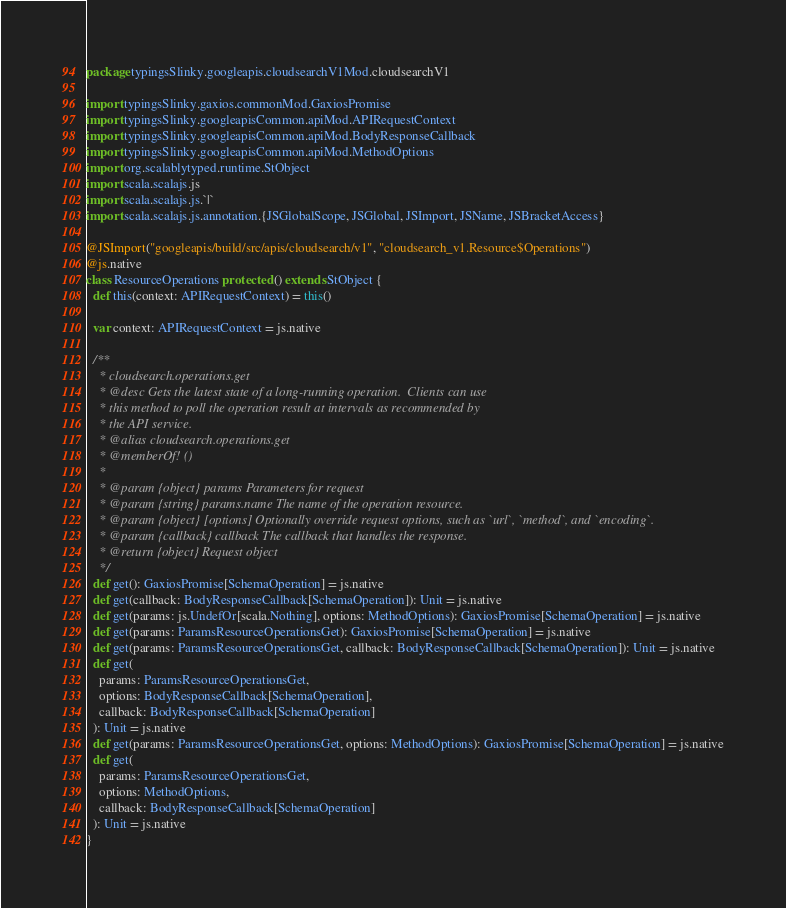Convert code to text. <code><loc_0><loc_0><loc_500><loc_500><_Scala_>package typingsSlinky.googleapis.cloudsearchV1Mod.cloudsearchV1

import typingsSlinky.gaxios.commonMod.GaxiosPromise
import typingsSlinky.googleapisCommon.apiMod.APIRequestContext
import typingsSlinky.googleapisCommon.apiMod.BodyResponseCallback
import typingsSlinky.googleapisCommon.apiMod.MethodOptions
import org.scalablytyped.runtime.StObject
import scala.scalajs.js
import scala.scalajs.js.`|`
import scala.scalajs.js.annotation.{JSGlobalScope, JSGlobal, JSImport, JSName, JSBracketAccess}

@JSImport("googleapis/build/src/apis/cloudsearch/v1", "cloudsearch_v1.Resource$Operations")
@js.native
class ResourceOperations protected () extends StObject {
  def this(context: APIRequestContext) = this()
  
  var context: APIRequestContext = js.native
  
  /**
    * cloudsearch.operations.get
    * @desc Gets the latest state of a long-running operation.  Clients can use
    * this method to poll the operation result at intervals as recommended by
    * the API service.
    * @alias cloudsearch.operations.get
    * @memberOf! ()
    *
    * @param {object} params Parameters for request
    * @param {string} params.name The name of the operation resource.
    * @param {object} [options] Optionally override request options, such as `url`, `method`, and `encoding`.
    * @param {callback} callback The callback that handles the response.
    * @return {object} Request object
    */
  def get(): GaxiosPromise[SchemaOperation] = js.native
  def get(callback: BodyResponseCallback[SchemaOperation]): Unit = js.native
  def get(params: js.UndefOr[scala.Nothing], options: MethodOptions): GaxiosPromise[SchemaOperation] = js.native
  def get(params: ParamsResourceOperationsGet): GaxiosPromise[SchemaOperation] = js.native
  def get(params: ParamsResourceOperationsGet, callback: BodyResponseCallback[SchemaOperation]): Unit = js.native
  def get(
    params: ParamsResourceOperationsGet,
    options: BodyResponseCallback[SchemaOperation],
    callback: BodyResponseCallback[SchemaOperation]
  ): Unit = js.native
  def get(params: ParamsResourceOperationsGet, options: MethodOptions): GaxiosPromise[SchemaOperation] = js.native
  def get(
    params: ParamsResourceOperationsGet,
    options: MethodOptions,
    callback: BodyResponseCallback[SchemaOperation]
  ): Unit = js.native
}
</code> 